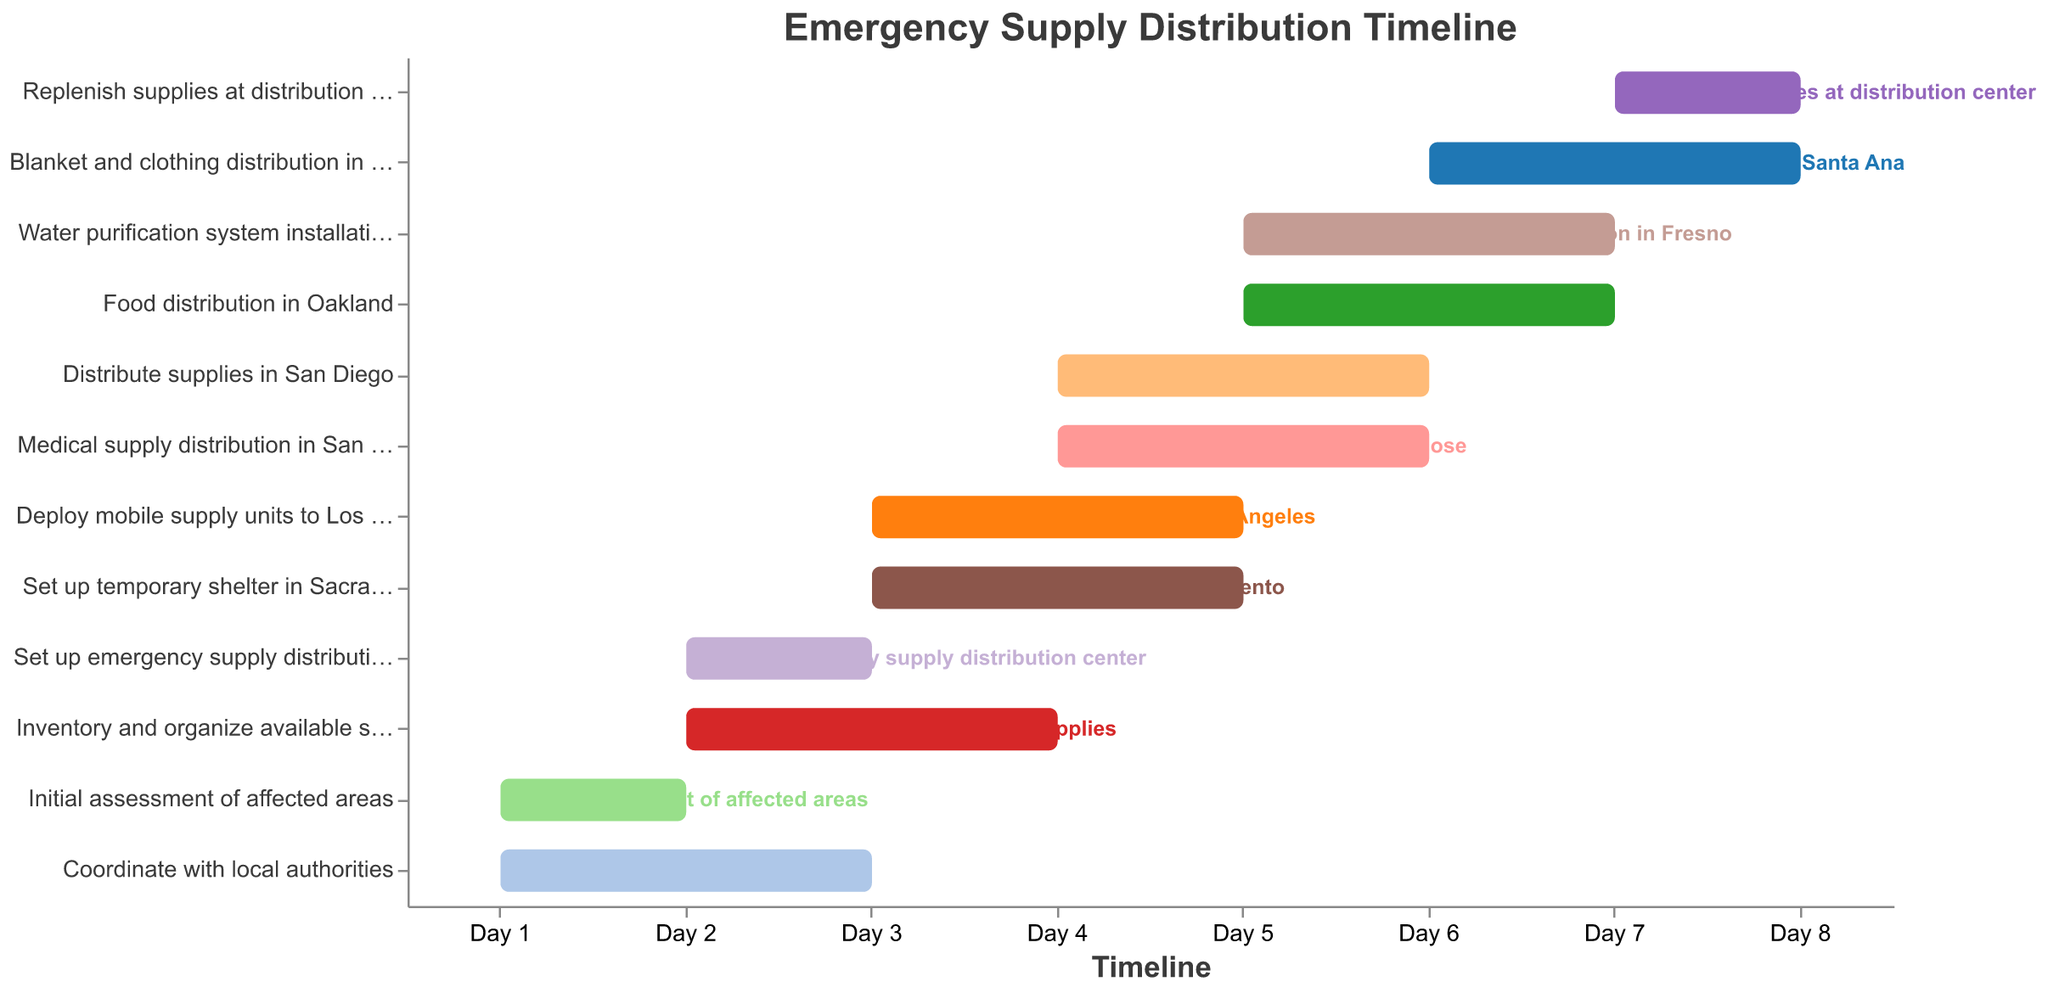What's the title of the figure? Look at the top of the Gantt chart to find the title displayed.
Answer: Emergency Supply Distribution Timeline Which tasks start on Day 1? Examine the starting points on the horizontal axis for Day 1 to see which tasks are aligned with it.
Answer: Initial assessment of affected areas, Coordinate with local authorities Which task has the longest duration? Identify the tasks by calculating the difference between their start and end days. Compare durations to find the longest one.
Answer: Inventory and organize available supplies What tasks coincide on Day 5? Find the tasks that have either starting or ending points on Day 5 of the timeline.
Answer: Deploy mobile supply units to Los Angeles, Set up temporary shelter in Sacramento, Water purification system installation in Fresno, Distribute supplies in San Diego, Food distribution in Oakland How many tasks are scheduled to end by Day 4? Count the number of tasks that have "End" points on or before Day 4.
Answer: Four tasks Which task starts immediately after setting up the emergency supply distribution center? Look for the task starting right after "Set up emergency supply distribution center" ends on Day 3.
Answer: Deploy mobile supply units to Los Angeles When does the task "Water purification system installation in Fresno" start and end? Find the task "Water purification system installation in Fresno" and check its start and end points on the horizontal axis.
Answer: Starts on Day 5 and ends on Day 7 On which days are no new tasks scheduled to begin? Identify the days on the horizontal axis when no "Start" points are present.
Answer: Day 6 Which area will receive blankets and clothing, and on which days? Identify the task related to blanket and clothing distribution and check the timeline.
Answer: Santa Ana, from Day 6 to Day 8 What is the total number of tasks scheduled on the timeline? Count the number of unique tasks listed on the vertical axis of the Gantt chart.
Answer: Twelve tasks 